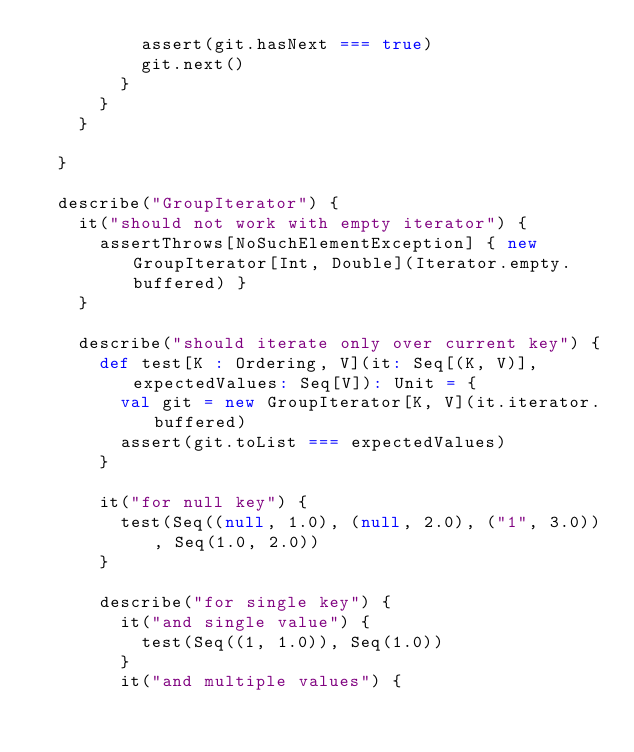Convert code to text. <code><loc_0><loc_0><loc_500><loc_500><_Scala_>          assert(git.hasNext === true)
          git.next()
        }
      }
    }

  }

  describe("GroupIterator") {
    it("should not work with empty iterator") {
      assertThrows[NoSuchElementException] { new GroupIterator[Int, Double](Iterator.empty.buffered) }
    }

    describe("should iterate only over current key") {
      def test[K : Ordering, V](it: Seq[(K, V)], expectedValues: Seq[V]): Unit = {
        val git = new GroupIterator[K, V](it.iterator.buffered)
        assert(git.toList === expectedValues)
      }

      it("for null key") {
        test(Seq((null, 1.0), (null, 2.0), ("1", 3.0)), Seq(1.0, 2.0))
      }

      describe("for single key") {
        it("and single value") {
          test(Seq((1, 1.0)), Seq(1.0))
        }
        it("and multiple values") {</code> 